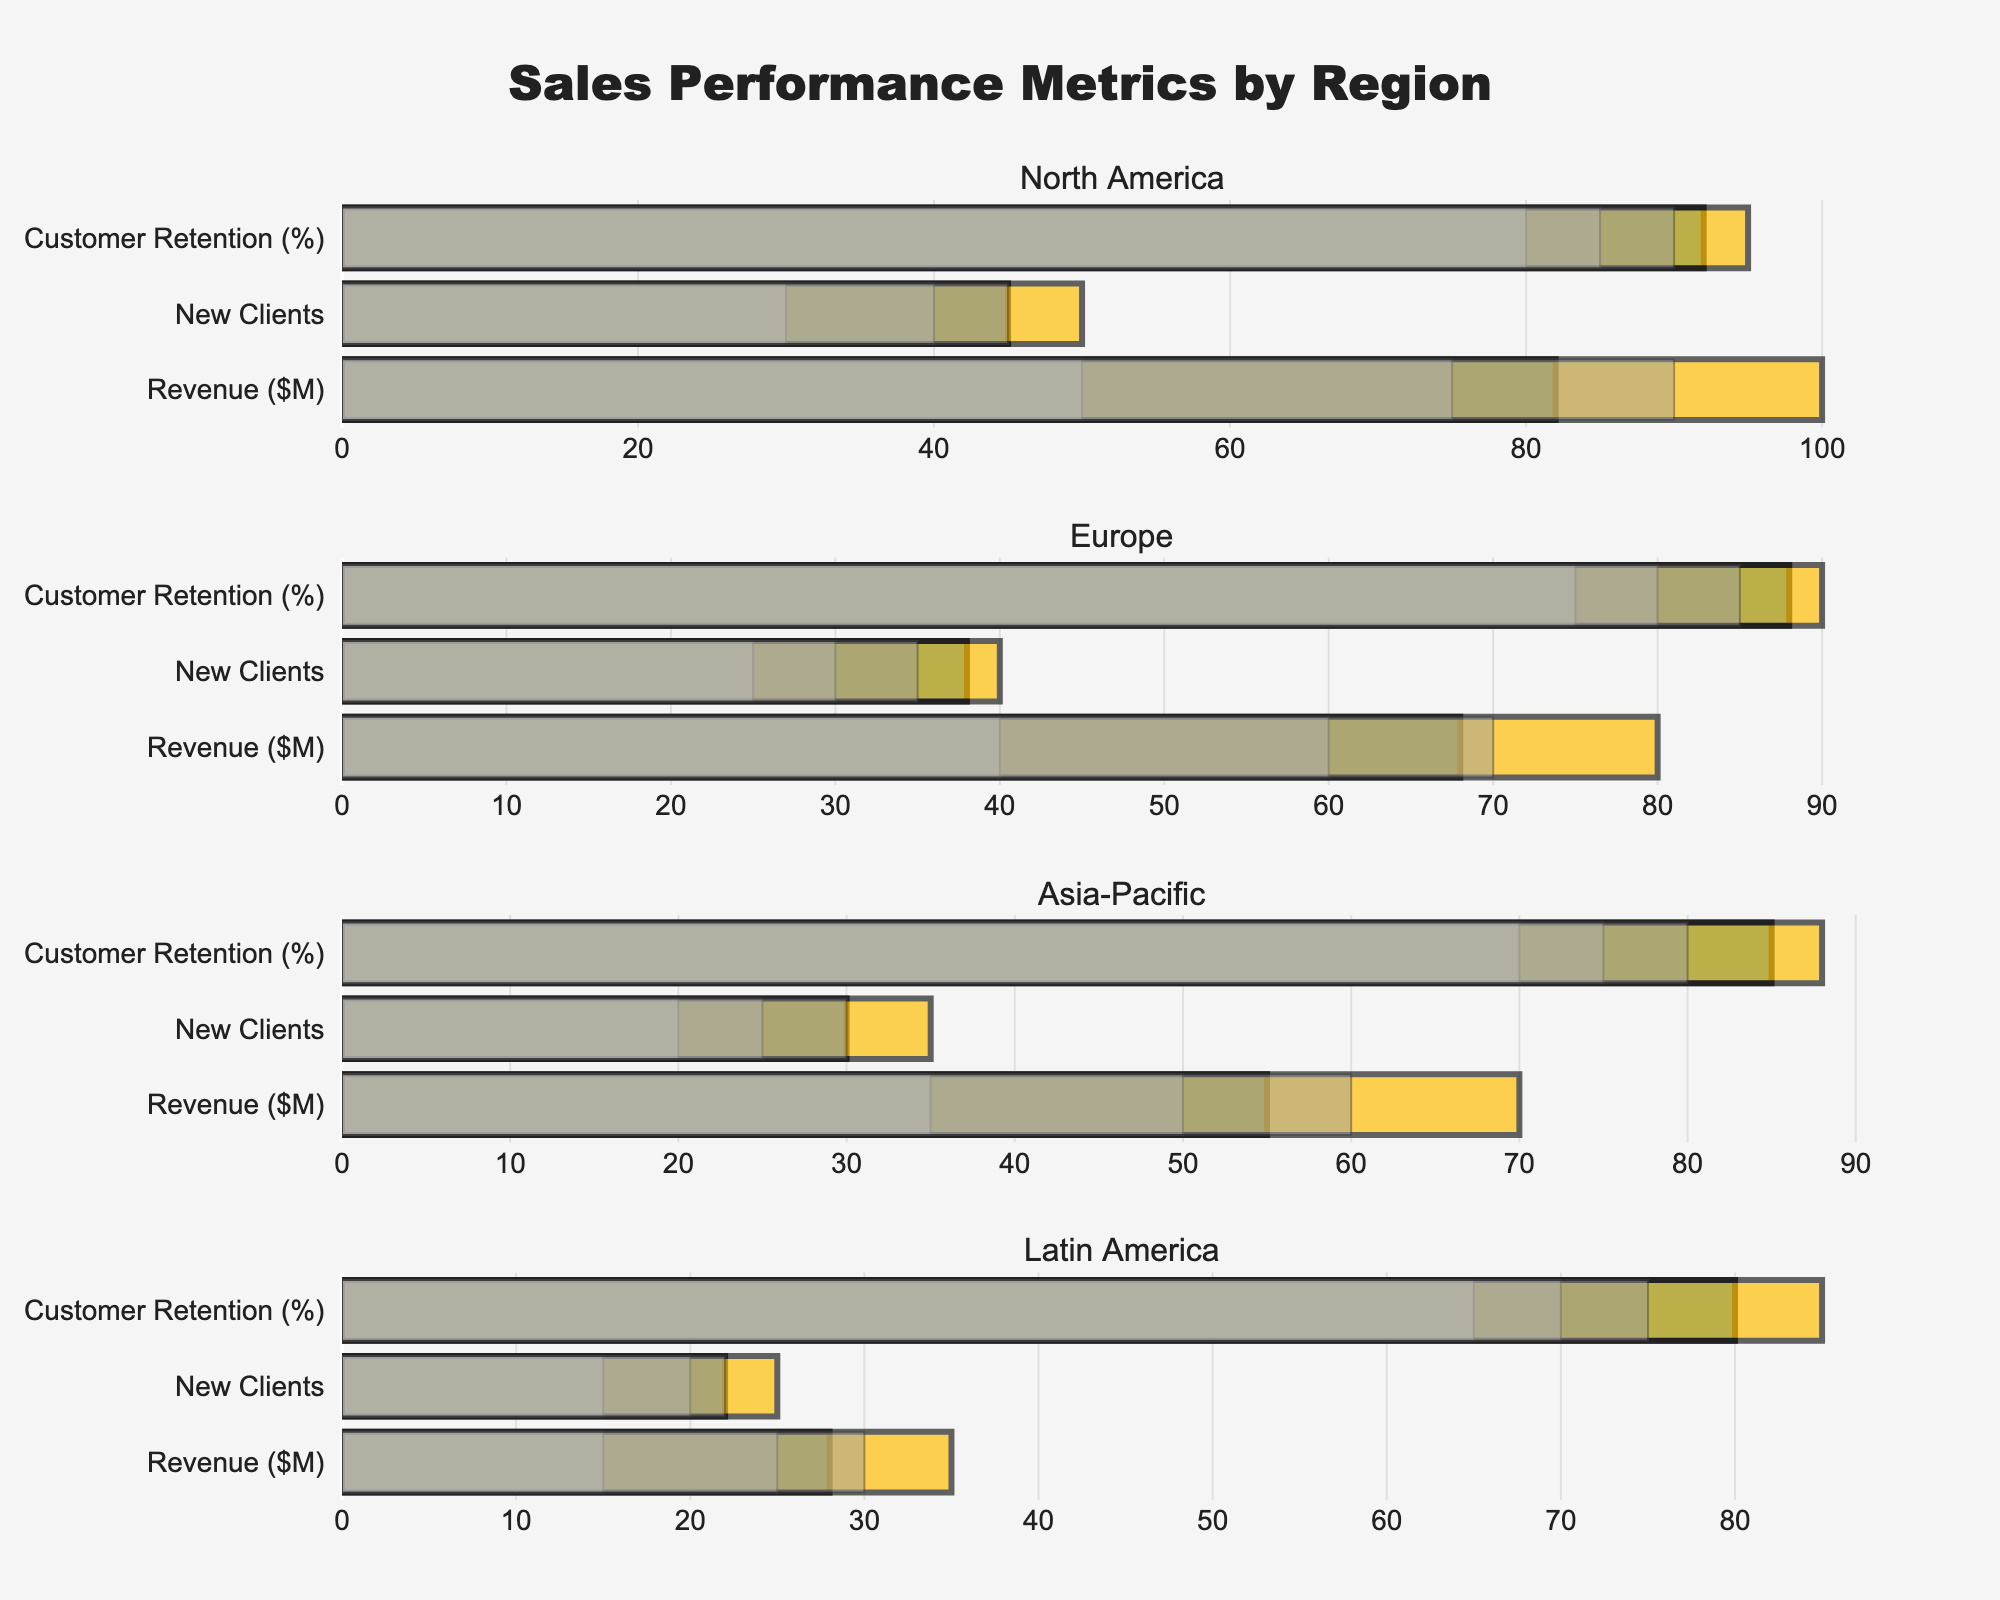What is the title of the figure? The title is usually positioned at the top of the figure and describes its content or theme. In this case, it reads "Sales Performance Metrics by Region".
Answer: Sales Performance Metrics by Region What is the actual revenue for North America, and how does it compare to the target? Look at the bar labeled "Revenue ($M)" under the "North America" section. The actual revenue is shown as a blue bar with a label. The orange bar adjacent to it marks the target. The actual revenue is 82, while the target is 100. So, the actual revenue is lower than the target by 18 million dollars.
Answer: 82 (lower by 18) How many new clients did Europe acquire, and is it within the target range? Check the bar labeled "New Clients" under the "Europe" section. The blue bar represents the actual number of new clients, which is 38. The target is 40. Since 38 is below 40, Europe did not meet its target but is quite close to it.
Answer: 38 (below target) What are the ranges for customer retention in the Asia-Pacific region, and did the actual performance fall within the best range? In the "Asia-Pacific" section, find the bar labeled "Customer Retention (%)". The gray shades represent Range1 (best), Range2 (good), and Range3 (acceptable). The values are 70, 75, and 80 respectively. The actual retention is 85, which is higher than the best range of 80.
Answer: 70, 75, 80 (above the best range) Which region has the lowest revenue achievement compared to its target? Compare the blue bars representing "Revenue ($M)" for all regions and see which one is the lowest compared to its orange target bar. Latin America has an actual revenue of 28 against a target of 35, which shows the biggest shortfall.
Answer: Latin America Did North America achieve its target for new clients? The "New Clients" bar in North America shows the actual value as 45, while the target is 50. Comparing these, North America did not meet the target for new clients.
Answer: No What is the customer retention percentage of Europe, and is it in the best range? In the "Europe" section, the "Customer Retention (%)" bar shows the actual retention percentage of 88. The ranges are 75, 80, and 85 for acceptable, good, and best respectively. Since 88 is higher than 85, it is in the best range.
Answer: 88 (in the best range) What is the total number of new clients acquired across all regions? Add the values of new clients for all regions: North America (45), Europe (38), Asia-Pacific (30), and Latin America (22). The total is 45 + 38 + 30 + 22 = 135.
Answer: 135 Which two regions have the closest actual revenue performances? Compare the blue bars labeled "Revenue ($M)" for all regions to find the closest values. North America (82) and Europe (68) are the closest, with a difference of 14 million dollars.
Answer: North America and Europe What percentage gap exists between the actual and target customer retention for North America? Look at North America's "Customer Retention (%)" bar. The actual retention is 92, and the target is 95. The percentage gap is (95 - 92) / 95 * 100 = 3.16%.
Answer: 3.16% 